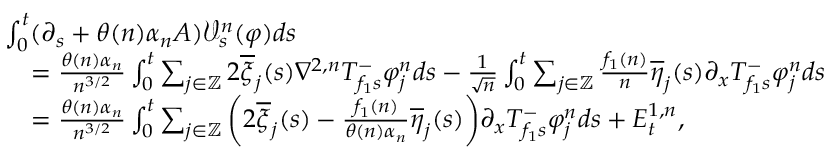<formula> <loc_0><loc_0><loc_500><loc_500>\begin{array} { r l } & { \int _ { 0 } ^ { t } ( \partial _ { s } + \theta ( n ) \alpha _ { n } A ) \mathcal { V } _ { s } ^ { n } ( \varphi ) d s } \\ & { \quad = \frac { \theta ( n ) \alpha _ { n } } { n ^ { 3 / 2 } } \int _ { 0 } ^ { t } \sum _ { j \in \mathbb { Z } } 2 \overline { \xi } _ { j } ( s ) \nabla ^ { 2 , n } T _ { f _ { 1 } s } ^ { - } \varphi _ { j } ^ { n } d s - \frac { 1 } { \sqrt { n } } \int _ { 0 } ^ { t } \sum _ { j \in \mathbb { Z } } \frac { f _ { 1 } ( n ) } { n } \overline { \eta } _ { j } ( s ) \partial _ { x } T _ { f _ { 1 } s } ^ { - } \varphi _ { j } ^ { n } d s } \\ & { \quad = \frac { \theta ( n ) \alpha _ { n } } { n ^ { 3 / 2 } } \int _ { 0 } ^ { t } \sum _ { j \in \mathbb { Z } } \left ( 2 \overline { \xi } _ { j } ( s ) - \frac { f _ { 1 } ( n ) } { \theta ( n ) \alpha _ { n } } \overline { \eta } _ { j } ( s ) \right ) \partial _ { x } T _ { f _ { 1 } s } ^ { - } \varphi _ { j } ^ { n } d s + E _ { t } ^ { 1 , n } , } \end{array}</formula> 